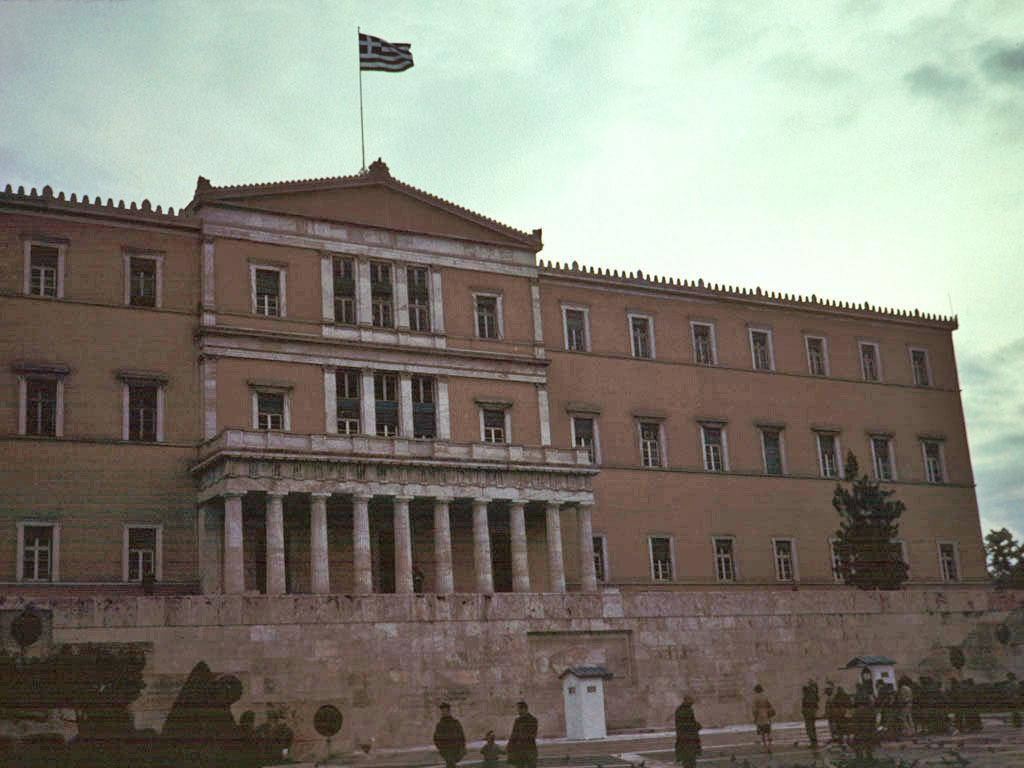What type of structure is visible in the image? There is a building in the image. What feature can be seen on the building? There is a flagpole on the building. Are there any people present in the image? Yes, there are people standing in the image. What type of vegetation is visible in the image? There are trees in the image. How would you describe the sky in the image? The sky is cloudy in the image. What type of curve can be seen in the flesh of the people in the image? There is no mention of any curves or flesh in the image; it only features a building, a flagpole, people, trees, and a cloudy sky. 